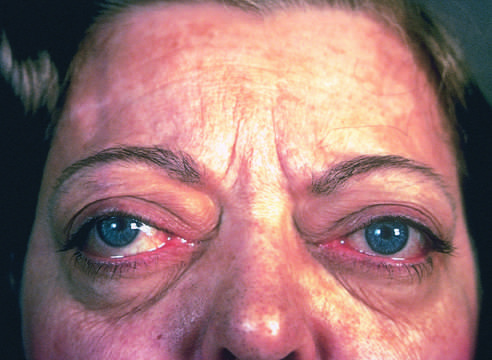what adds to the protuberant appearance of the eyes in graves disease?
Answer the question using a single word or phrase. The orbits 